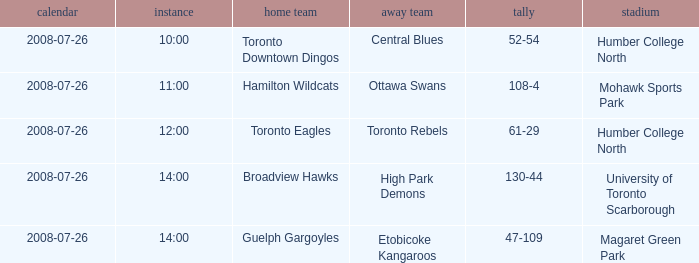When did the High Park Demons play Away? 2008-07-26. 